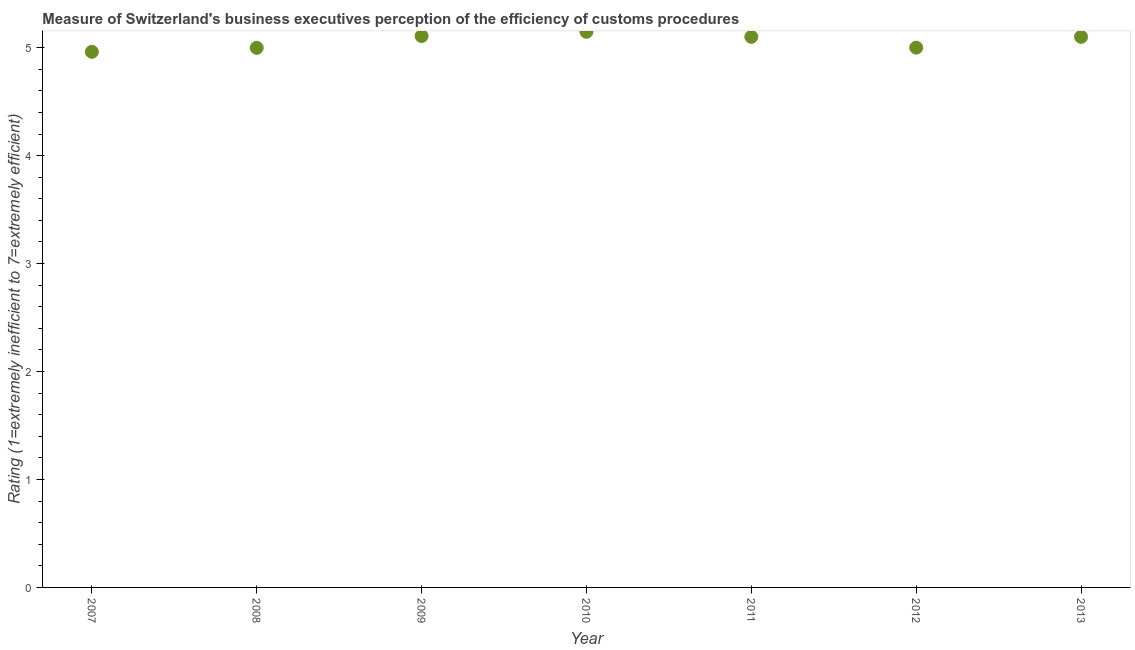What is the rating measuring burden of customs procedure in 2007?
Your response must be concise. 4.96. Across all years, what is the maximum rating measuring burden of customs procedure?
Offer a very short reply. 5.15. Across all years, what is the minimum rating measuring burden of customs procedure?
Your answer should be very brief. 4.96. What is the sum of the rating measuring burden of customs procedure?
Your response must be concise. 35.41. What is the difference between the rating measuring burden of customs procedure in 2007 and 2008?
Offer a terse response. -0.04. What is the average rating measuring burden of customs procedure per year?
Offer a terse response. 5.06. What is the median rating measuring burden of customs procedure?
Ensure brevity in your answer.  5.1. In how many years, is the rating measuring burden of customs procedure greater than 3.4 ?
Provide a succinct answer. 7. Do a majority of the years between 2009 and 2008 (inclusive) have rating measuring burden of customs procedure greater than 1.2 ?
Offer a very short reply. No. What is the ratio of the rating measuring burden of customs procedure in 2011 to that in 2012?
Keep it short and to the point. 1.02. What is the difference between the highest and the second highest rating measuring burden of customs procedure?
Keep it short and to the point. 0.04. Is the sum of the rating measuring burden of customs procedure in 2011 and 2013 greater than the maximum rating measuring burden of customs procedure across all years?
Keep it short and to the point. Yes. What is the difference between the highest and the lowest rating measuring burden of customs procedure?
Offer a very short reply. 0.19. In how many years, is the rating measuring burden of customs procedure greater than the average rating measuring burden of customs procedure taken over all years?
Offer a very short reply. 4. How many dotlines are there?
Your answer should be compact. 1. How many years are there in the graph?
Keep it short and to the point. 7. Are the values on the major ticks of Y-axis written in scientific E-notation?
Offer a very short reply. No. Does the graph contain any zero values?
Offer a terse response. No. What is the title of the graph?
Provide a short and direct response. Measure of Switzerland's business executives perception of the efficiency of customs procedures. What is the label or title of the X-axis?
Your answer should be compact. Year. What is the label or title of the Y-axis?
Ensure brevity in your answer.  Rating (1=extremely inefficient to 7=extremely efficient). What is the Rating (1=extremely inefficient to 7=extremely efficient) in 2007?
Provide a short and direct response. 4.96. What is the Rating (1=extremely inefficient to 7=extremely efficient) in 2008?
Provide a short and direct response. 5. What is the Rating (1=extremely inefficient to 7=extremely efficient) in 2009?
Offer a terse response. 5.11. What is the Rating (1=extremely inefficient to 7=extremely efficient) in 2010?
Ensure brevity in your answer.  5.15. What is the difference between the Rating (1=extremely inefficient to 7=extremely efficient) in 2007 and 2008?
Your answer should be compact. -0.04. What is the difference between the Rating (1=extremely inefficient to 7=extremely efficient) in 2007 and 2009?
Give a very brief answer. -0.15. What is the difference between the Rating (1=extremely inefficient to 7=extremely efficient) in 2007 and 2010?
Offer a terse response. -0.19. What is the difference between the Rating (1=extremely inefficient to 7=extremely efficient) in 2007 and 2011?
Offer a very short reply. -0.14. What is the difference between the Rating (1=extremely inefficient to 7=extremely efficient) in 2007 and 2012?
Give a very brief answer. -0.04. What is the difference between the Rating (1=extremely inefficient to 7=extremely efficient) in 2007 and 2013?
Give a very brief answer. -0.14. What is the difference between the Rating (1=extremely inefficient to 7=extremely efficient) in 2008 and 2009?
Provide a short and direct response. -0.11. What is the difference between the Rating (1=extremely inefficient to 7=extremely efficient) in 2008 and 2010?
Provide a short and direct response. -0.15. What is the difference between the Rating (1=extremely inefficient to 7=extremely efficient) in 2008 and 2011?
Make the answer very short. -0.1. What is the difference between the Rating (1=extremely inefficient to 7=extremely efficient) in 2008 and 2012?
Keep it short and to the point. -0. What is the difference between the Rating (1=extremely inefficient to 7=extremely efficient) in 2008 and 2013?
Ensure brevity in your answer.  -0.1. What is the difference between the Rating (1=extremely inefficient to 7=extremely efficient) in 2009 and 2010?
Keep it short and to the point. -0.04. What is the difference between the Rating (1=extremely inefficient to 7=extremely efficient) in 2009 and 2011?
Your answer should be compact. 0.01. What is the difference between the Rating (1=extremely inefficient to 7=extremely efficient) in 2009 and 2012?
Offer a terse response. 0.11. What is the difference between the Rating (1=extremely inefficient to 7=extremely efficient) in 2009 and 2013?
Ensure brevity in your answer.  0.01. What is the difference between the Rating (1=extremely inefficient to 7=extremely efficient) in 2010 and 2011?
Provide a succinct answer. 0.05. What is the difference between the Rating (1=extremely inefficient to 7=extremely efficient) in 2010 and 2012?
Ensure brevity in your answer.  0.15. What is the difference between the Rating (1=extremely inefficient to 7=extremely efficient) in 2010 and 2013?
Make the answer very short. 0.05. What is the difference between the Rating (1=extremely inefficient to 7=extremely efficient) in 2011 and 2012?
Provide a succinct answer. 0.1. What is the ratio of the Rating (1=extremely inefficient to 7=extremely efficient) in 2007 to that in 2008?
Provide a succinct answer. 0.99. What is the ratio of the Rating (1=extremely inefficient to 7=extremely efficient) in 2007 to that in 2009?
Offer a terse response. 0.97. What is the ratio of the Rating (1=extremely inefficient to 7=extremely efficient) in 2007 to that in 2011?
Offer a very short reply. 0.97. What is the ratio of the Rating (1=extremely inefficient to 7=extremely efficient) in 2007 to that in 2012?
Offer a terse response. 0.99. What is the ratio of the Rating (1=extremely inefficient to 7=extremely efficient) in 2007 to that in 2013?
Your answer should be very brief. 0.97. What is the ratio of the Rating (1=extremely inefficient to 7=extremely efficient) in 2008 to that in 2009?
Your response must be concise. 0.98. What is the ratio of the Rating (1=extremely inefficient to 7=extremely efficient) in 2008 to that in 2010?
Provide a short and direct response. 0.97. What is the ratio of the Rating (1=extremely inefficient to 7=extremely efficient) in 2008 to that in 2011?
Your answer should be compact. 0.98. What is the ratio of the Rating (1=extremely inefficient to 7=extremely efficient) in 2009 to that in 2011?
Give a very brief answer. 1. What is the ratio of the Rating (1=extremely inefficient to 7=extremely efficient) in 2009 to that in 2012?
Your response must be concise. 1.02. What is the ratio of the Rating (1=extremely inefficient to 7=extremely efficient) in 2009 to that in 2013?
Ensure brevity in your answer.  1. What is the ratio of the Rating (1=extremely inefficient to 7=extremely efficient) in 2010 to that in 2011?
Your answer should be compact. 1.01. What is the ratio of the Rating (1=extremely inefficient to 7=extremely efficient) in 2010 to that in 2012?
Your answer should be compact. 1.03. What is the ratio of the Rating (1=extremely inefficient to 7=extremely efficient) in 2010 to that in 2013?
Provide a short and direct response. 1.01. 